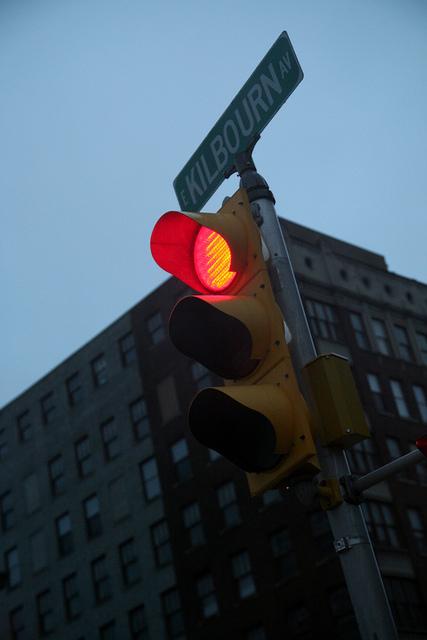What letter does the street name begin with?
Give a very brief answer. K. What color is the light?
Write a very short answer. Red. Does the building have a lot of windows?
Keep it brief. Yes. 